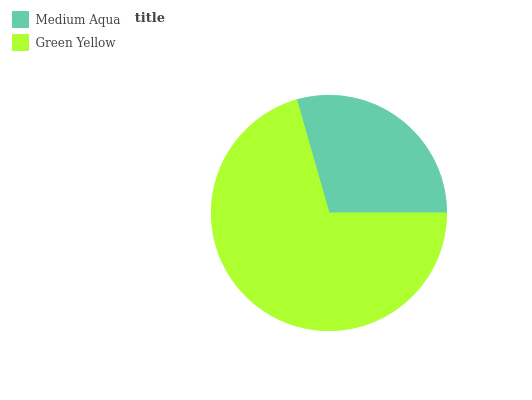Is Medium Aqua the minimum?
Answer yes or no. Yes. Is Green Yellow the maximum?
Answer yes or no. Yes. Is Green Yellow the minimum?
Answer yes or no. No. Is Green Yellow greater than Medium Aqua?
Answer yes or no. Yes. Is Medium Aqua less than Green Yellow?
Answer yes or no. Yes. Is Medium Aqua greater than Green Yellow?
Answer yes or no. No. Is Green Yellow less than Medium Aqua?
Answer yes or no. No. Is Green Yellow the high median?
Answer yes or no. Yes. Is Medium Aqua the low median?
Answer yes or no. Yes. Is Medium Aqua the high median?
Answer yes or no. No. Is Green Yellow the low median?
Answer yes or no. No. 